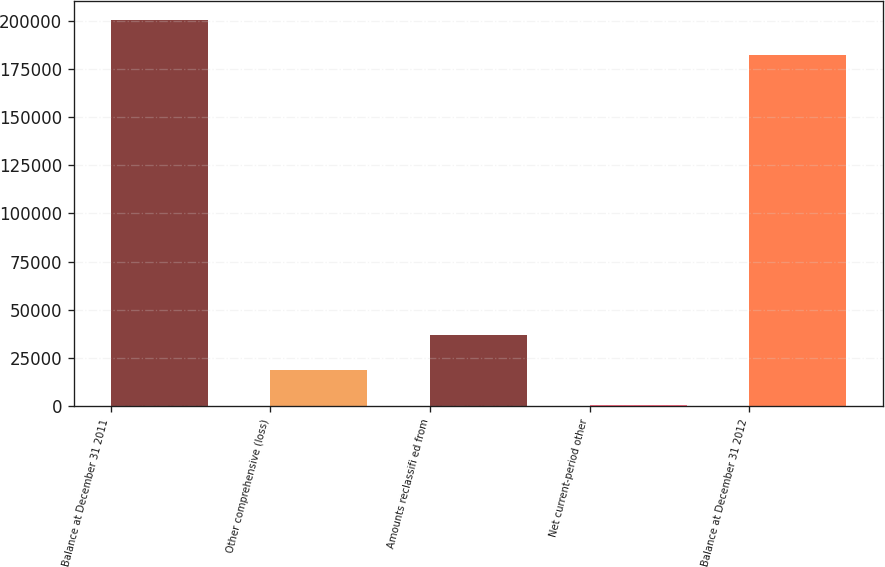Convert chart. <chart><loc_0><loc_0><loc_500><loc_500><bar_chart><fcel>Balance at December 31 2011<fcel>Other comprehensive (loss)<fcel>Amounts reclassifi ed from<fcel>Net current-period other<fcel>Balance at December 31 2012<nl><fcel>200441<fcel>18504.9<fcel>36726.8<fcel>283<fcel>182219<nl></chart> 